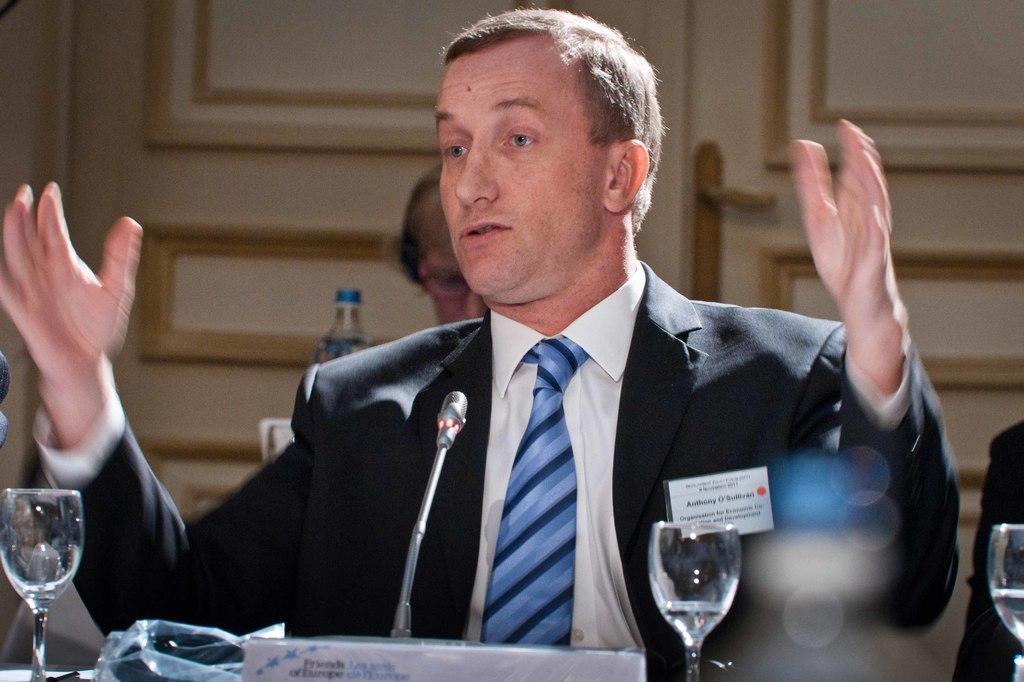Can you describe this image briefly? In this image we can see a man wearing a suit and there is a mic in front of him and we can see a board with the text and there are some other objects and there is a person behind the man. 